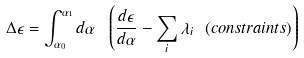<formula> <loc_0><loc_0><loc_500><loc_500>\Delta \epsilon = \int ^ { \alpha _ { 1 } } _ { \alpha _ { 0 } } d \alpha \ \left ( \frac { d \epsilon } { d \alpha } - \sum _ { i } \lambda _ { i } \ ( c o n s t r a i n t s ) \right )</formula> 